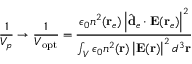Convert formula to latex. <formula><loc_0><loc_0><loc_500><loc_500>\frac { 1 } { V _ { p } } \rightarrow \frac { 1 } { V _ { o p t } } = \frac { \epsilon _ { 0 } n ^ { 2 } ( r _ { e } ) \left | \hat { d } _ { e } \cdot E ( r _ { e } ) \right | ^ { 2 } } { \int _ { V } \epsilon _ { 0 } n ^ { 2 } ( r ) \left | E ( r ) \right | ^ { 2 } d ^ { 3 } r }</formula> 